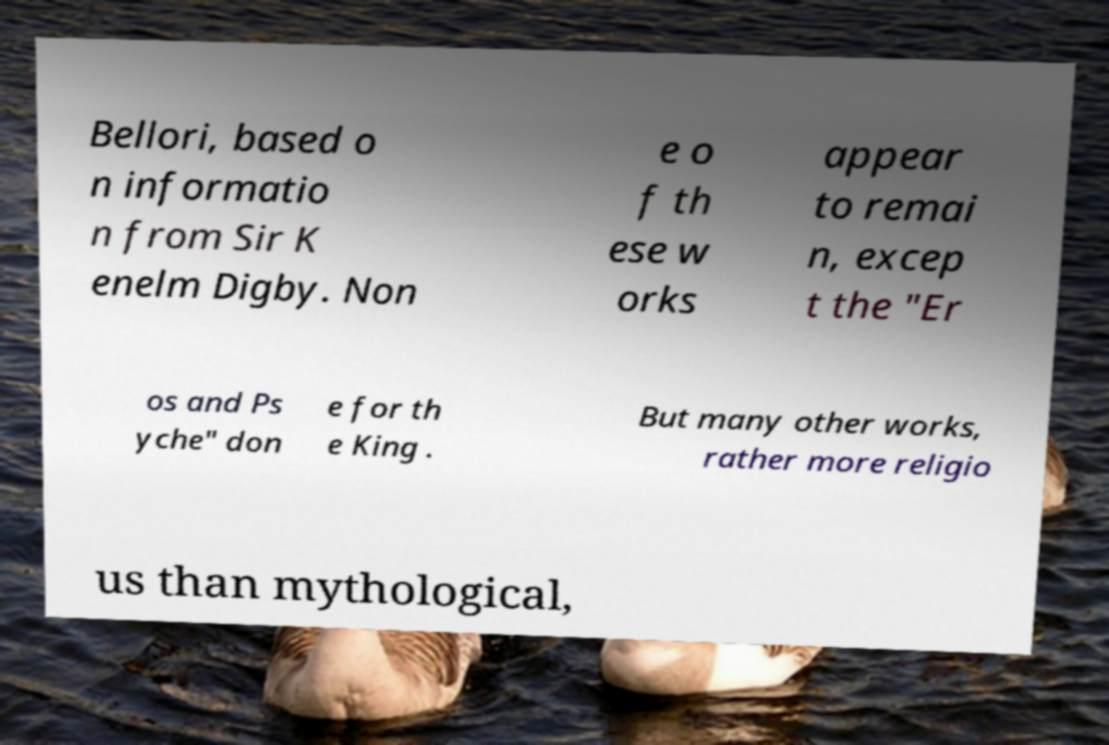For documentation purposes, I need the text within this image transcribed. Could you provide that? Bellori, based o n informatio n from Sir K enelm Digby. Non e o f th ese w orks appear to remai n, excep t the "Er os and Ps yche" don e for th e King . But many other works, rather more religio us than mythological, 